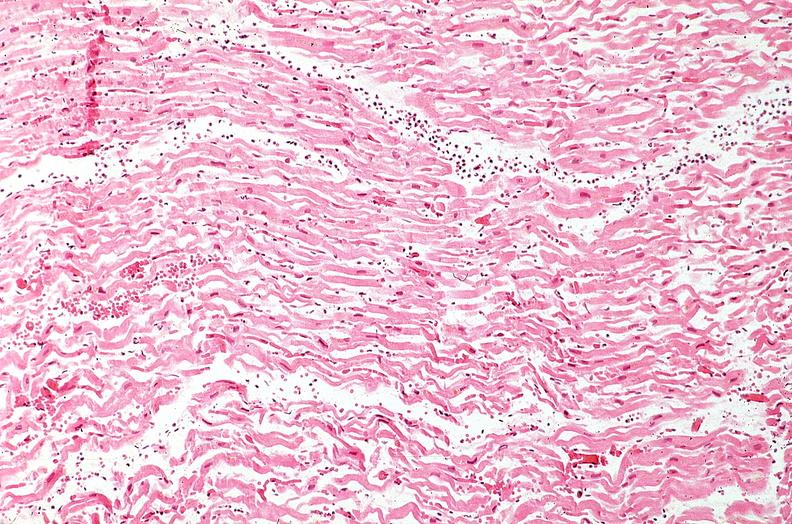s peritoneal fluid present?
Answer the question using a single word or phrase. No 